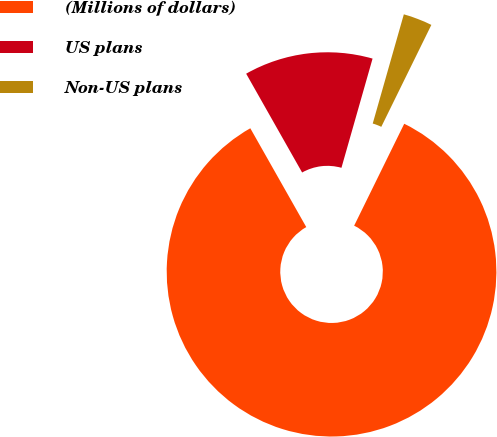Convert chart to OTSL. <chart><loc_0><loc_0><loc_500><loc_500><pie_chart><fcel>(Millions of dollars)<fcel>US plans<fcel>Non-US plans<nl><fcel>84.53%<fcel>12.62%<fcel>2.85%<nl></chart> 